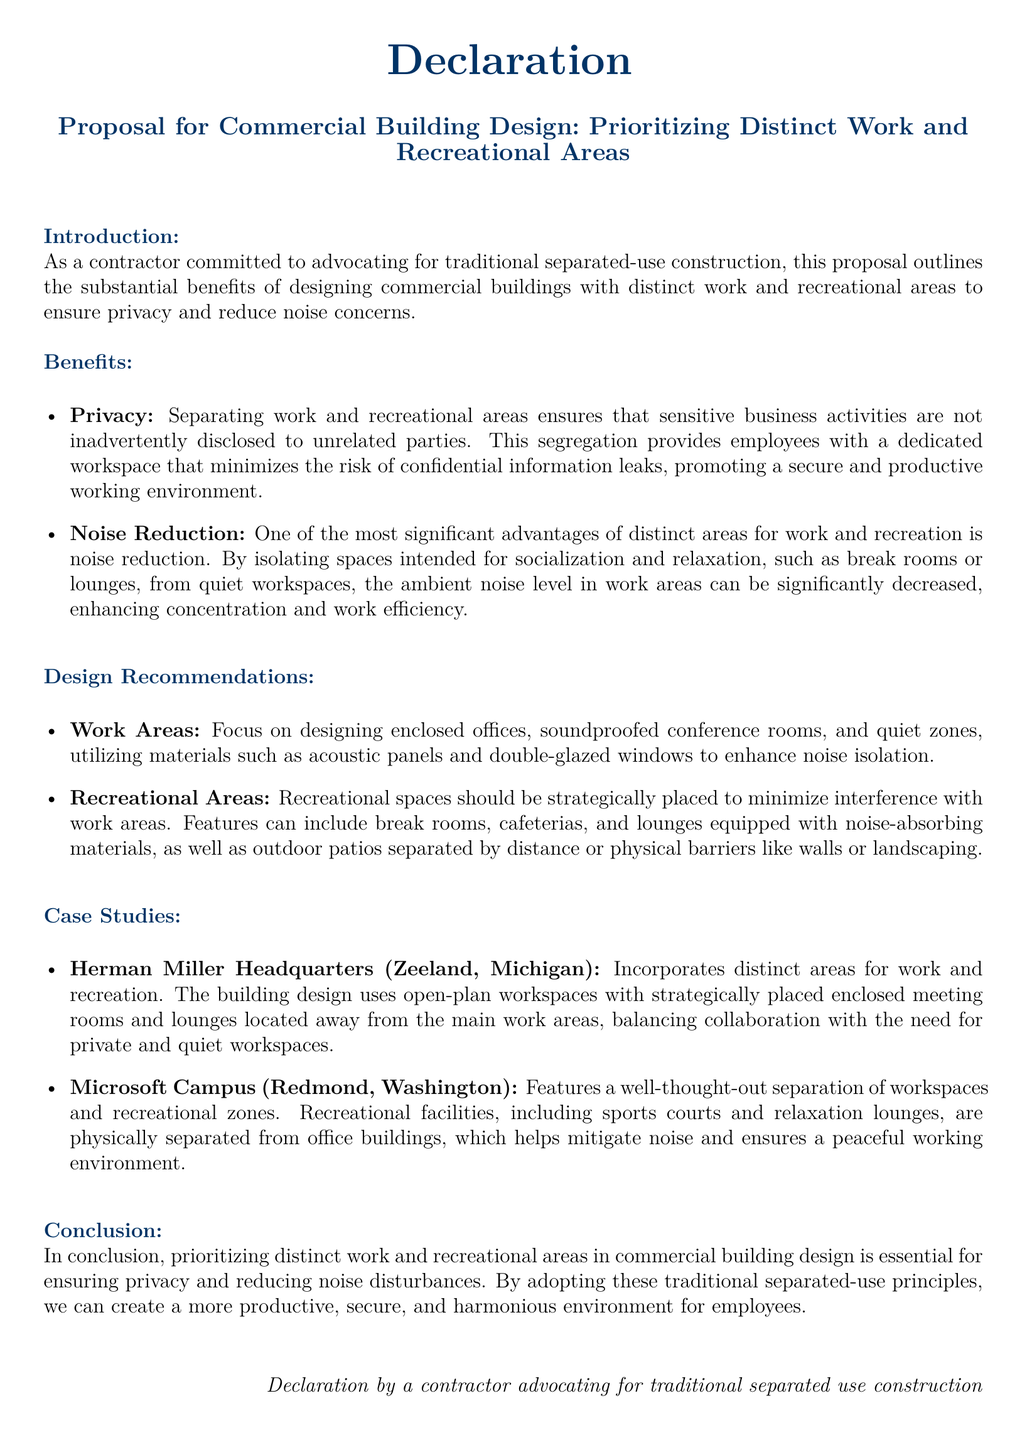What is the primary focus of the proposal? The proposal focuses on designing commercial buildings with distinct work and recreational areas.
Answer: Distinct work and recreational areas What two main benefits are highlighted in the proposal? The benefits highlighted are privacy and noise reduction.
Answer: Privacy and noise reduction What type of spaces are recommended for work areas? The document recommends designing enclosed offices, soundproofed conference rooms, and quiet zones.
Answer: Enclosed offices, soundproofed conference rooms, quiet zones Which company is mentioned as a case study for distinct work and recreational areas? Herman Miller Headquarters is mentioned as a case study in the document.
Answer: Herman Miller Headquarters What material is suggested for enhancing noise isolation in work areas? Acoustic panels are suggested for enhancing noise isolation.
Answer: Acoustic panels How does the document suggest recreational spaces should be placed? Recreational spaces should be strategically placed to minimize interference with work areas.
Answer: Strategically placed What is the location of the Microsoft Campus mentioned? The Microsoft Campus is located in Redmond, Washington.
Answer: Redmond, Washington What is the overall conclusion of the proposal? The conclusion states that prioritizing distinct work and recreational areas is essential for ensuring privacy and reducing noise disturbances.
Answer: Essential for ensuring privacy and reducing noise disturbances 